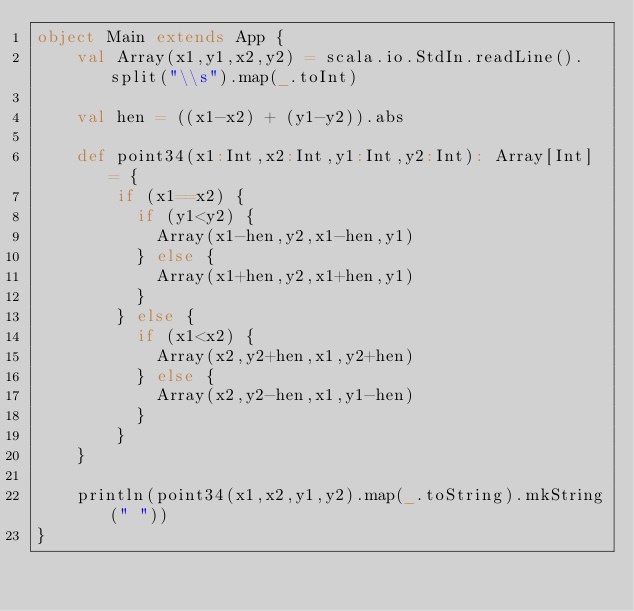Convert code to text. <code><loc_0><loc_0><loc_500><loc_500><_Scala_>object Main extends App {
    val Array(x1,y1,x2,y2) = scala.io.StdIn.readLine().split("\\s").map(_.toInt)

    val hen = ((x1-x2) + (y1-y2)).abs

    def point34(x1:Int,x2:Int,y1:Int,y2:Int): Array[Int] = {
        if (x1==x2) {
          if (y1<y2) {
            Array(x1-hen,y2,x1-hen,y1)
          } else {
            Array(x1+hen,y2,x1+hen,y1)
          }
        } else {
          if (x1<x2) {
            Array(x2,y2+hen,x1,y2+hen)
          } else {
            Array(x2,y2-hen,x1,y1-hen)
          }
        }
    }

    println(point34(x1,x2,y1,y2).map(_.toString).mkString(" "))
}</code> 